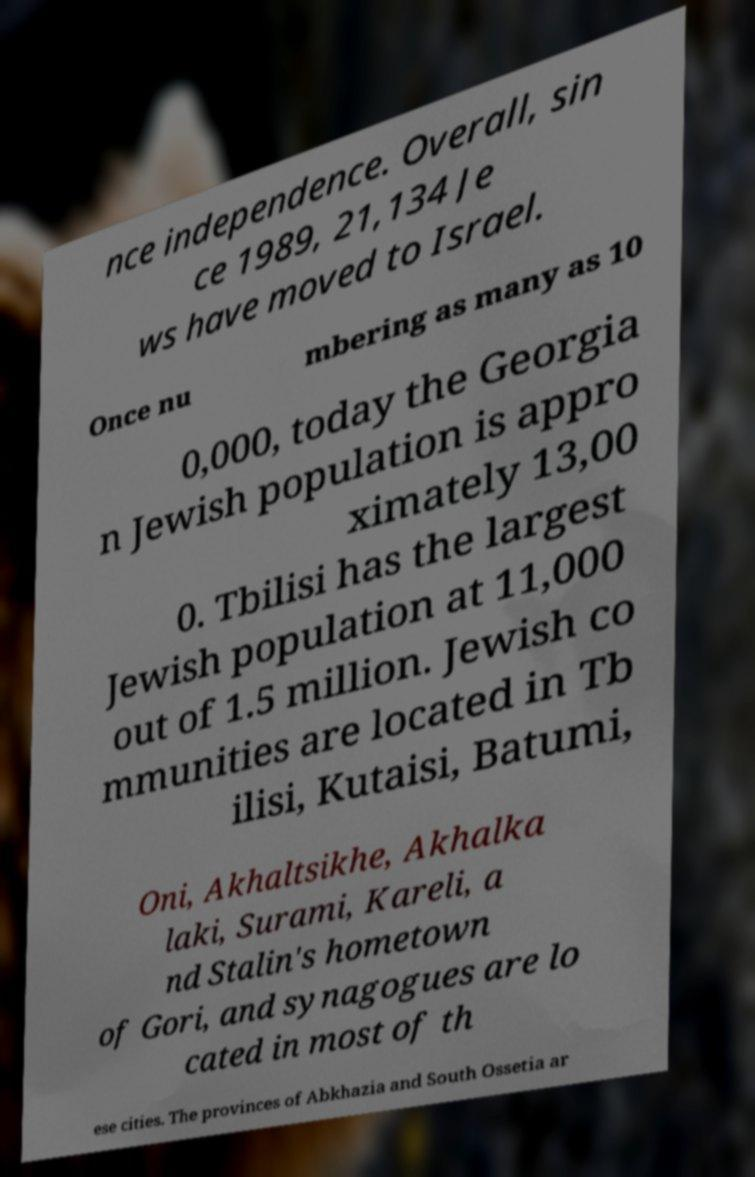There's text embedded in this image that I need extracted. Can you transcribe it verbatim? nce independence. Overall, sin ce 1989, 21,134 Je ws have moved to Israel. Once nu mbering as many as 10 0,000, today the Georgia n Jewish population is appro ximately 13,00 0. Tbilisi has the largest Jewish population at 11,000 out of 1.5 million. Jewish co mmunities are located in Tb ilisi, Kutaisi, Batumi, Oni, Akhaltsikhe, Akhalka laki, Surami, Kareli, a nd Stalin's hometown of Gori, and synagogues are lo cated in most of th ese cities. The provinces of Abkhazia and South Ossetia ar 